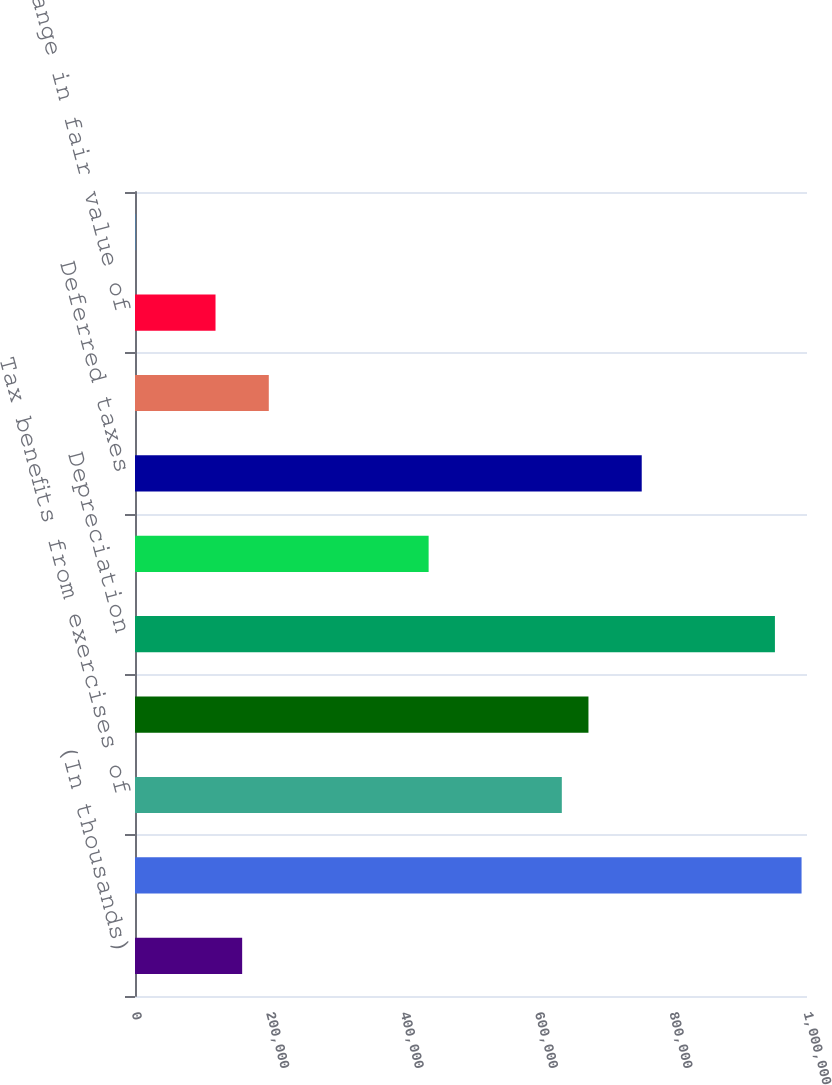Convert chart to OTSL. <chart><loc_0><loc_0><loc_500><loc_500><bar_chart><fcel>(In thousands)<fcel>Share-based compensation<fcel>Tax benefits from exercises of<fcel>Excess tax benefits from<fcel>Depreciation<fcel>Amortization of intangible<fcel>Deferred taxes<fcel>Provision for doubtful<fcel>Net change in fair value of<fcel>(Income) loss on equity<nl><fcel>159465<fcel>991908<fcel>635147<fcel>674787<fcel>952267<fcel>436946<fcel>754067<fcel>199106<fcel>119825<fcel>905<nl></chart> 